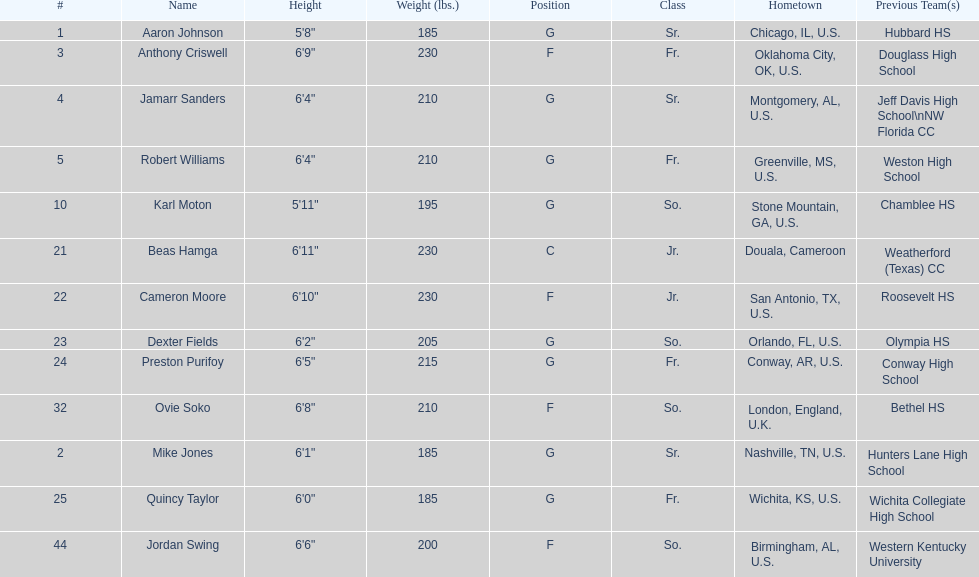Can you tell me the total seniors present in the team? 3. 